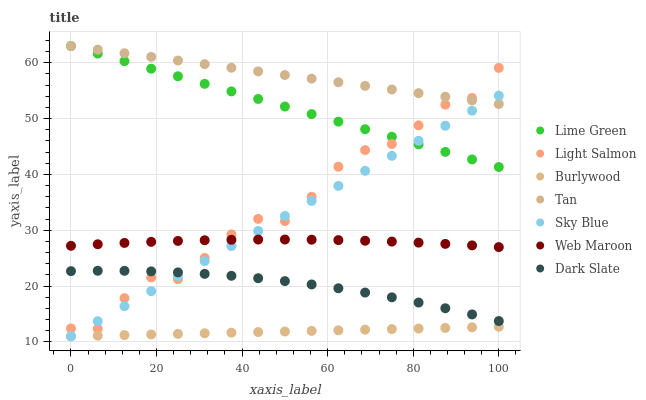Does Burlywood have the minimum area under the curve?
Answer yes or no. Yes. Does Tan have the maximum area under the curve?
Answer yes or no. Yes. Does Web Maroon have the minimum area under the curve?
Answer yes or no. No. Does Web Maroon have the maximum area under the curve?
Answer yes or no. No. Is Burlywood the smoothest?
Answer yes or no. Yes. Is Light Salmon the roughest?
Answer yes or no. Yes. Is Web Maroon the smoothest?
Answer yes or no. No. Is Web Maroon the roughest?
Answer yes or no. No. Does Burlywood have the lowest value?
Answer yes or no. Yes. Does Web Maroon have the lowest value?
Answer yes or no. No. Does Lime Green have the highest value?
Answer yes or no. Yes. Does Web Maroon have the highest value?
Answer yes or no. No. Is Burlywood less than Dark Slate?
Answer yes or no. Yes. Is Lime Green greater than Web Maroon?
Answer yes or no. Yes. Does Sky Blue intersect Lime Green?
Answer yes or no. Yes. Is Sky Blue less than Lime Green?
Answer yes or no. No. Is Sky Blue greater than Lime Green?
Answer yes or no. No. Does Burlywood intersect Dark Slate?
Answer yes or no. No. 